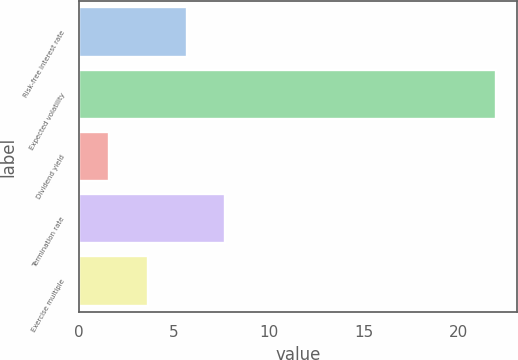Convert chart. <chart><loc_0><loc_0><loc_500><loc_500><bar_chart><fcel>Risk-free interest rate<fcel>Expected volatility<fcel>Dividend yield<fcel>Termination rate<fcel>Exercise multiple<nl><fcel>5.66<fcel>22<fcel>1.58<fcel>7.7<fcel>3.62<nl></chart> 